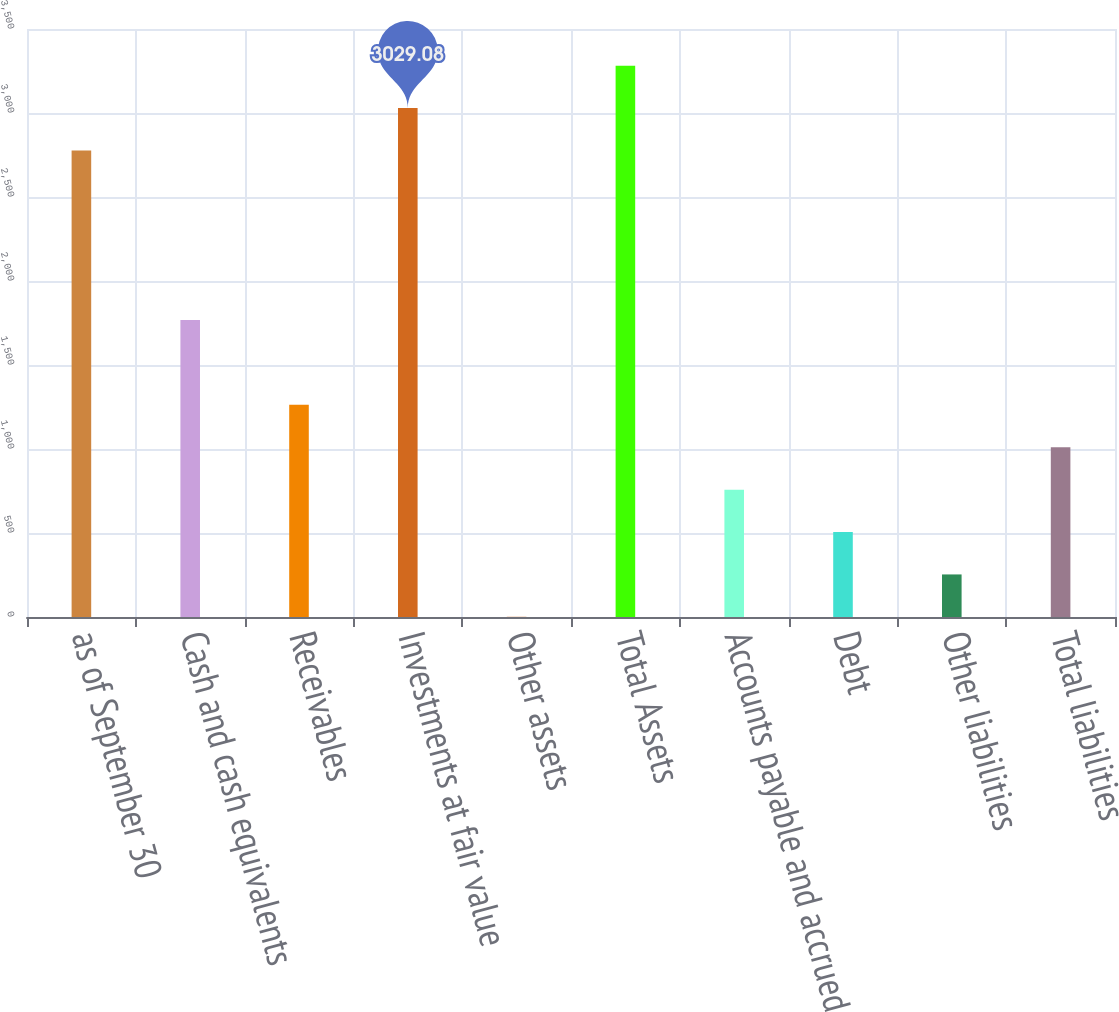<chart> <loc_0><loc_0><loc_500><loc_500><bar_chart><fcel>as of September 30<fcel>Cash and cash equivalents<fcel>Receivables<fcel>Investments at fair value<fcel>Other assets<fcel>Total Assets<fcel>Accounts payable and accrued<fcel>Debt<fcel>Other liabilities<fcel>Total liabilities<nl><fcel>2776.74<fcel>1767.38<fcel>1262.7<fcel>3029.08<fcel>1<fcel>3281.42<fcel>758.02<fcel>505.68<fcel>253.34<fcel>1010.36<nl></chart> 